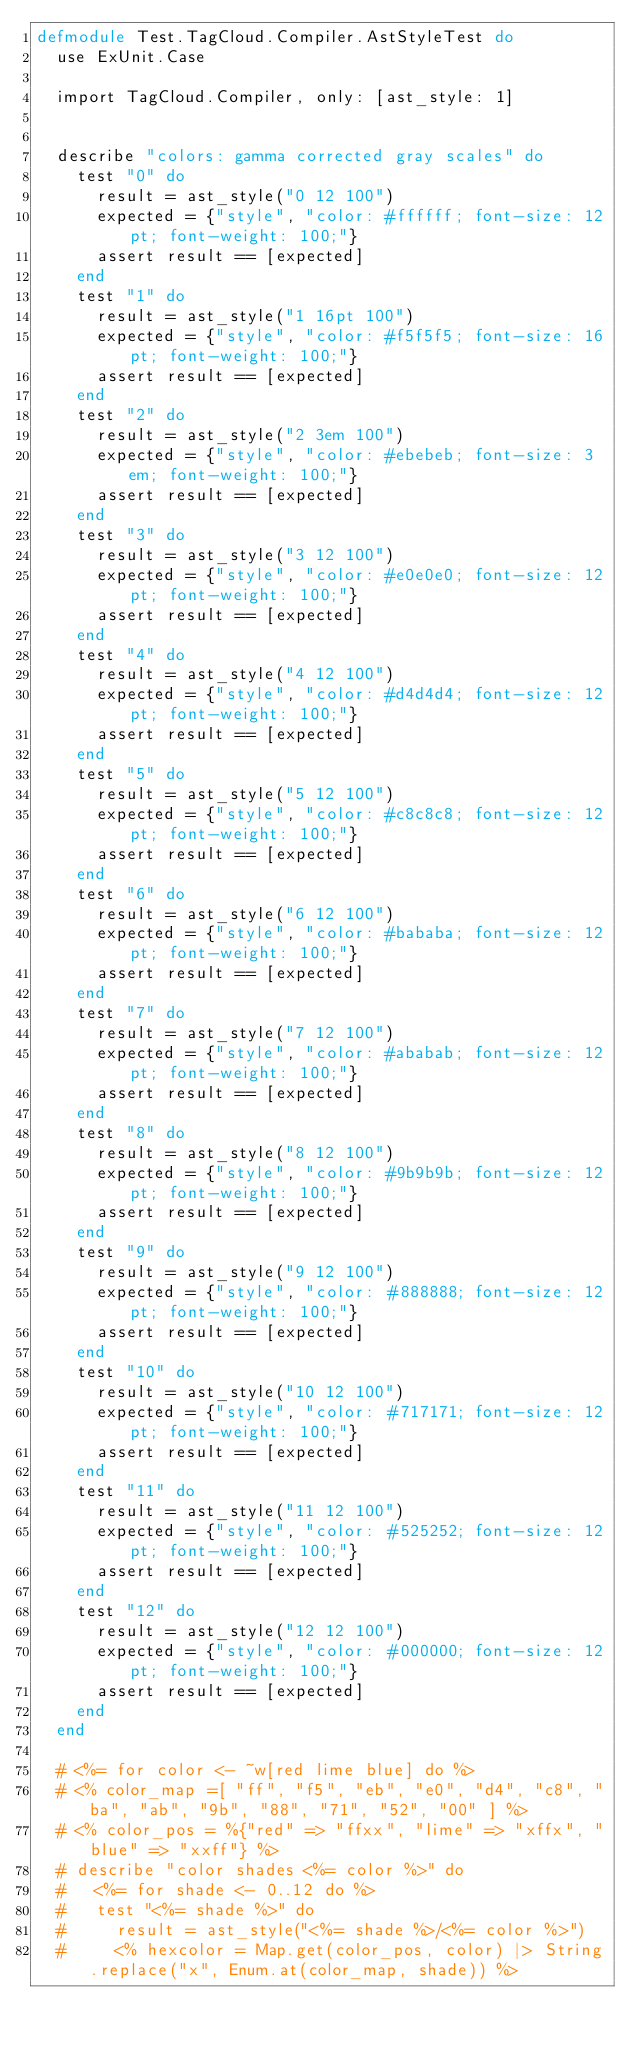Convert code to text. <code><loc_0><loc_0><loc_500><loc_500><_Elixir_>defmodule Test.TagCloud.Compiler.AstStyleTest do
  use ExUnit.Case

  import TagCloud.Compiler, only: [ast_style: 1]


  describe "colors: gamma corrected gray scales" do
    test "0" do
      result = ast_style("0 12 100")
      expected = {"style", "color: #ffffff; font-size: 12pt; font-weight: 100;"}
      assert result == [expected]
    end
    test "1" do
      result = ast_style("1 16pt 100")
      expected = {"style", "color: #f5f5f5; font-size: 16pt; font-weight: 100;"}
      assert result == [expected]
    end
    test "2" do
      result = ast_style("2 3em 100")
      expected = {"style", "color: #ebebeb; font-size: 3em; font-weight: 100;"}
      assert result == [expected]
    end
    test "3" do
      result = ast_style("3 12 100")
      expected = {"style", "color: #e0e0e0; font-size: 12pt; font-weight: 100;"}
      assert result == [expected]
    end
    test "4" do
      result = ast_style("4 12 100")
      expected = {"style", "color: #d4d4d4; font-size: 12pt; font-weight: 100;"}
      assert result == [expected]
    end
    test "5" do
      result = ast_style("5 12 100")
      expected = {"style", "color: #c8c8c8; font-size: 12pt; font-weight: 100;"}
      assert result == [expected]
    end
    test "6" do
      result = ast_style("6 12 100")
      expected = {"style", "color: #bababa; font-size: 12pt; font-weight: 100;"}
      assert result == [expected]
    end
    test "7" do
      result = ast_style("7 12 100")
      expected = {"style", "color: #ababab; font-size: 12pt; font-weight: 100;"}
      assert result == [expected]
    end
    test "8" do
      result = ast_style("8 12 100")
      expected = {"style", "color: #9b9b9b; font-size: 12pt; font-weight: 100;"}
      assert result == [expected]
    end
    test "9" do
      result = ast_style("9 12 100")
      expected = {"style", "color: #888888; font-size: 12pt; font-weight: 100;"}
      assert result == [expected]
    end
    test "10" do
      result = ast_style("10 12 100")
      expected = {"style", "color: #717171; font-size: 12pt; font-weight: 100;"}
      assert result == [expected]
    end
    test "11" do
      result = ast_style("11 12 100")
      expected = {"style", "color: #525252; font-size: 12pt; font-weight: 100;"}
      assert result == [expected]
    end
    test "12" do
      result = ast_style("12 12 100")
      expected = {"style", "color: #000000; font-size: 12pt; font-weight: 100;"}
      assert result == [expected]
    end
  end

  # <%= for color <- ~w[red lime blue] do %>
  # <% color_map =[ "ff", "f5", "eb", "e0", "d4", "c8", "ba", "ab", "9b", "88", "71", "52", "00" ] %>
  # <% color_pos = %{"red" => "ffxx", "lime" => "xffx", "blue" => "xxff"} %>
  # describe "color shades <%= color %>" do
  #   <%= for shade <- 0..12 do %>
  #   test "<%= shade %>" do
  #     result = ast_style("<%= shade %>/<%= color %>")
  #     <% hexcolor = Map.get(color_pos, color) |> String.replace("x", Enum.at(color_map, shade)) %></code> 